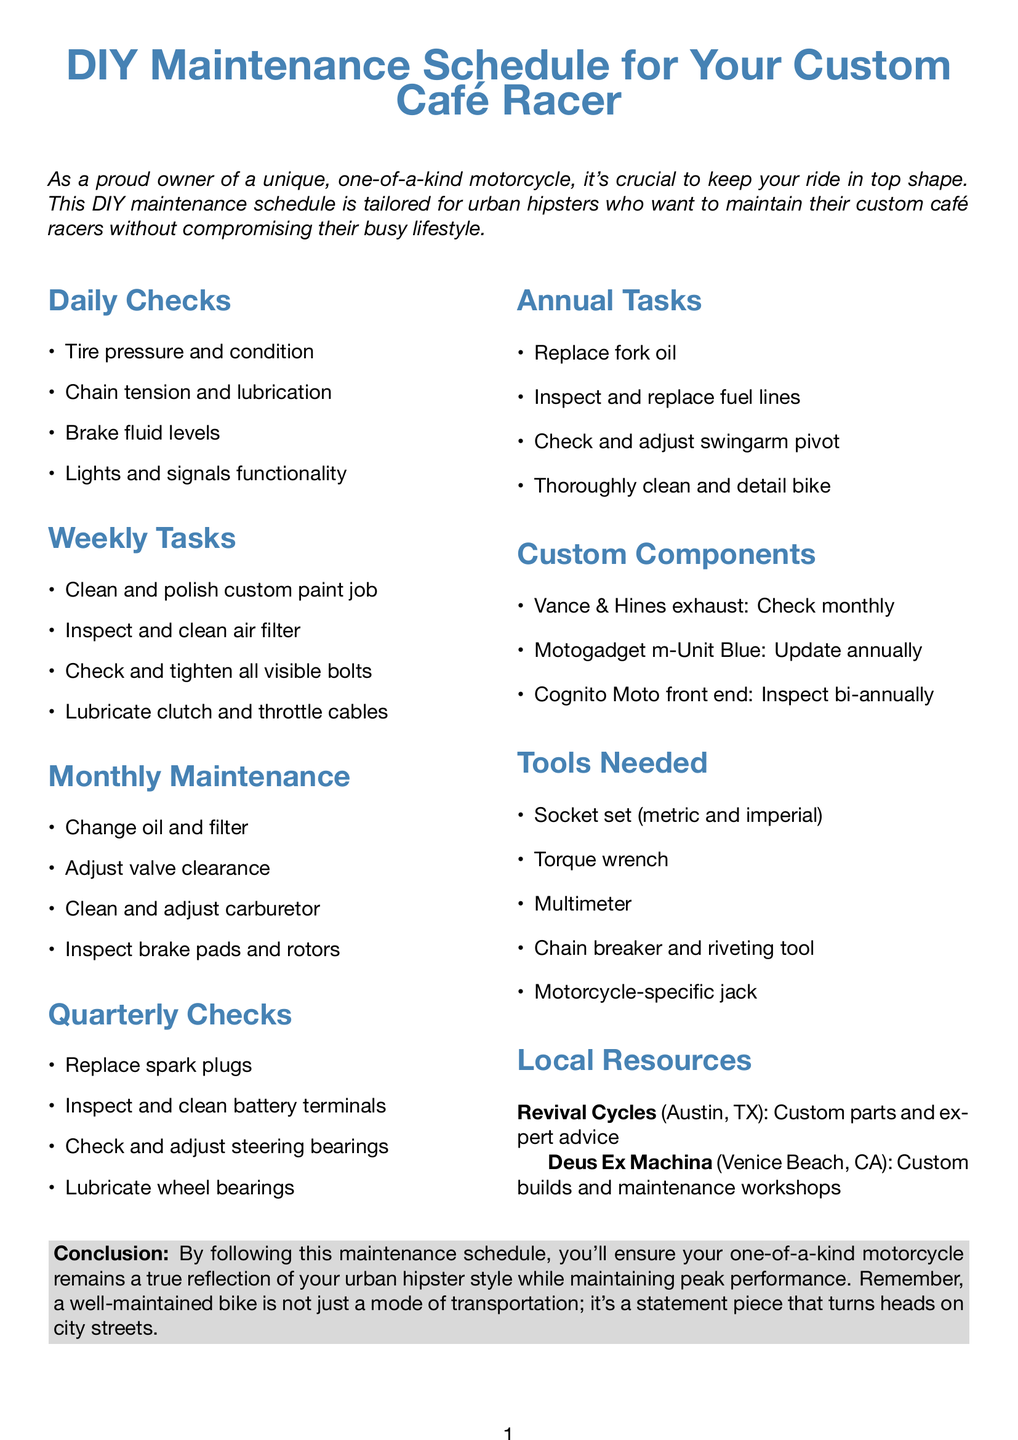what is the title of the document? The document's title is prominently displayed at the top, indicating its primary focus on motorcycle maintenance.
Answer: DIY Maintenance Schedule for Your Custom Café Racer how often should I replace spark plugs? The document specifies that spark plugs should be replaced every quarter, making it clear when this task should be undertaken.
Answer: Quarterly what is recommended for oil and filter change? The document provides a specific product recommendation for changing oil and filter, indicating preferred brand and type.
Answer: Motul 7100 4T 10W-40 where is Revival Cycles located? The location of Revival Cycles, a resource mentioned in the document, is noted to provide helpful information for the reader.
Answer: Austin, TX what is one task to perform daily? The document lists daily checks that riders should perform, and one of them exemplifies a key aspect of motorcycle maintenance.
Answer: Tire pressure and condition how often should I clean the air filter? The document outlines weekly tasks, indicating a regular maintenance item that contributes to the bike's overall performance.
Answer: Weekly which tool is required for chain maintenance? The tools needed section of the document specifies necessary tools for maintaining the motorcycle's chain, focusing on essential equipment.
Answer: Chain breaker and riveting tool when should you check the Vance & Hines exhaust system? The maintenance schedule for custom components includes frequency for checking specific parts, emphasizing ongoing inspection needs.
Answer: Monthly what is the main focus of the conclusion? The conclusion summarizes the importance of maintenance and its impact on the motorcycle's representation of the owner's style.
Answer: Peak performance and statement piece 